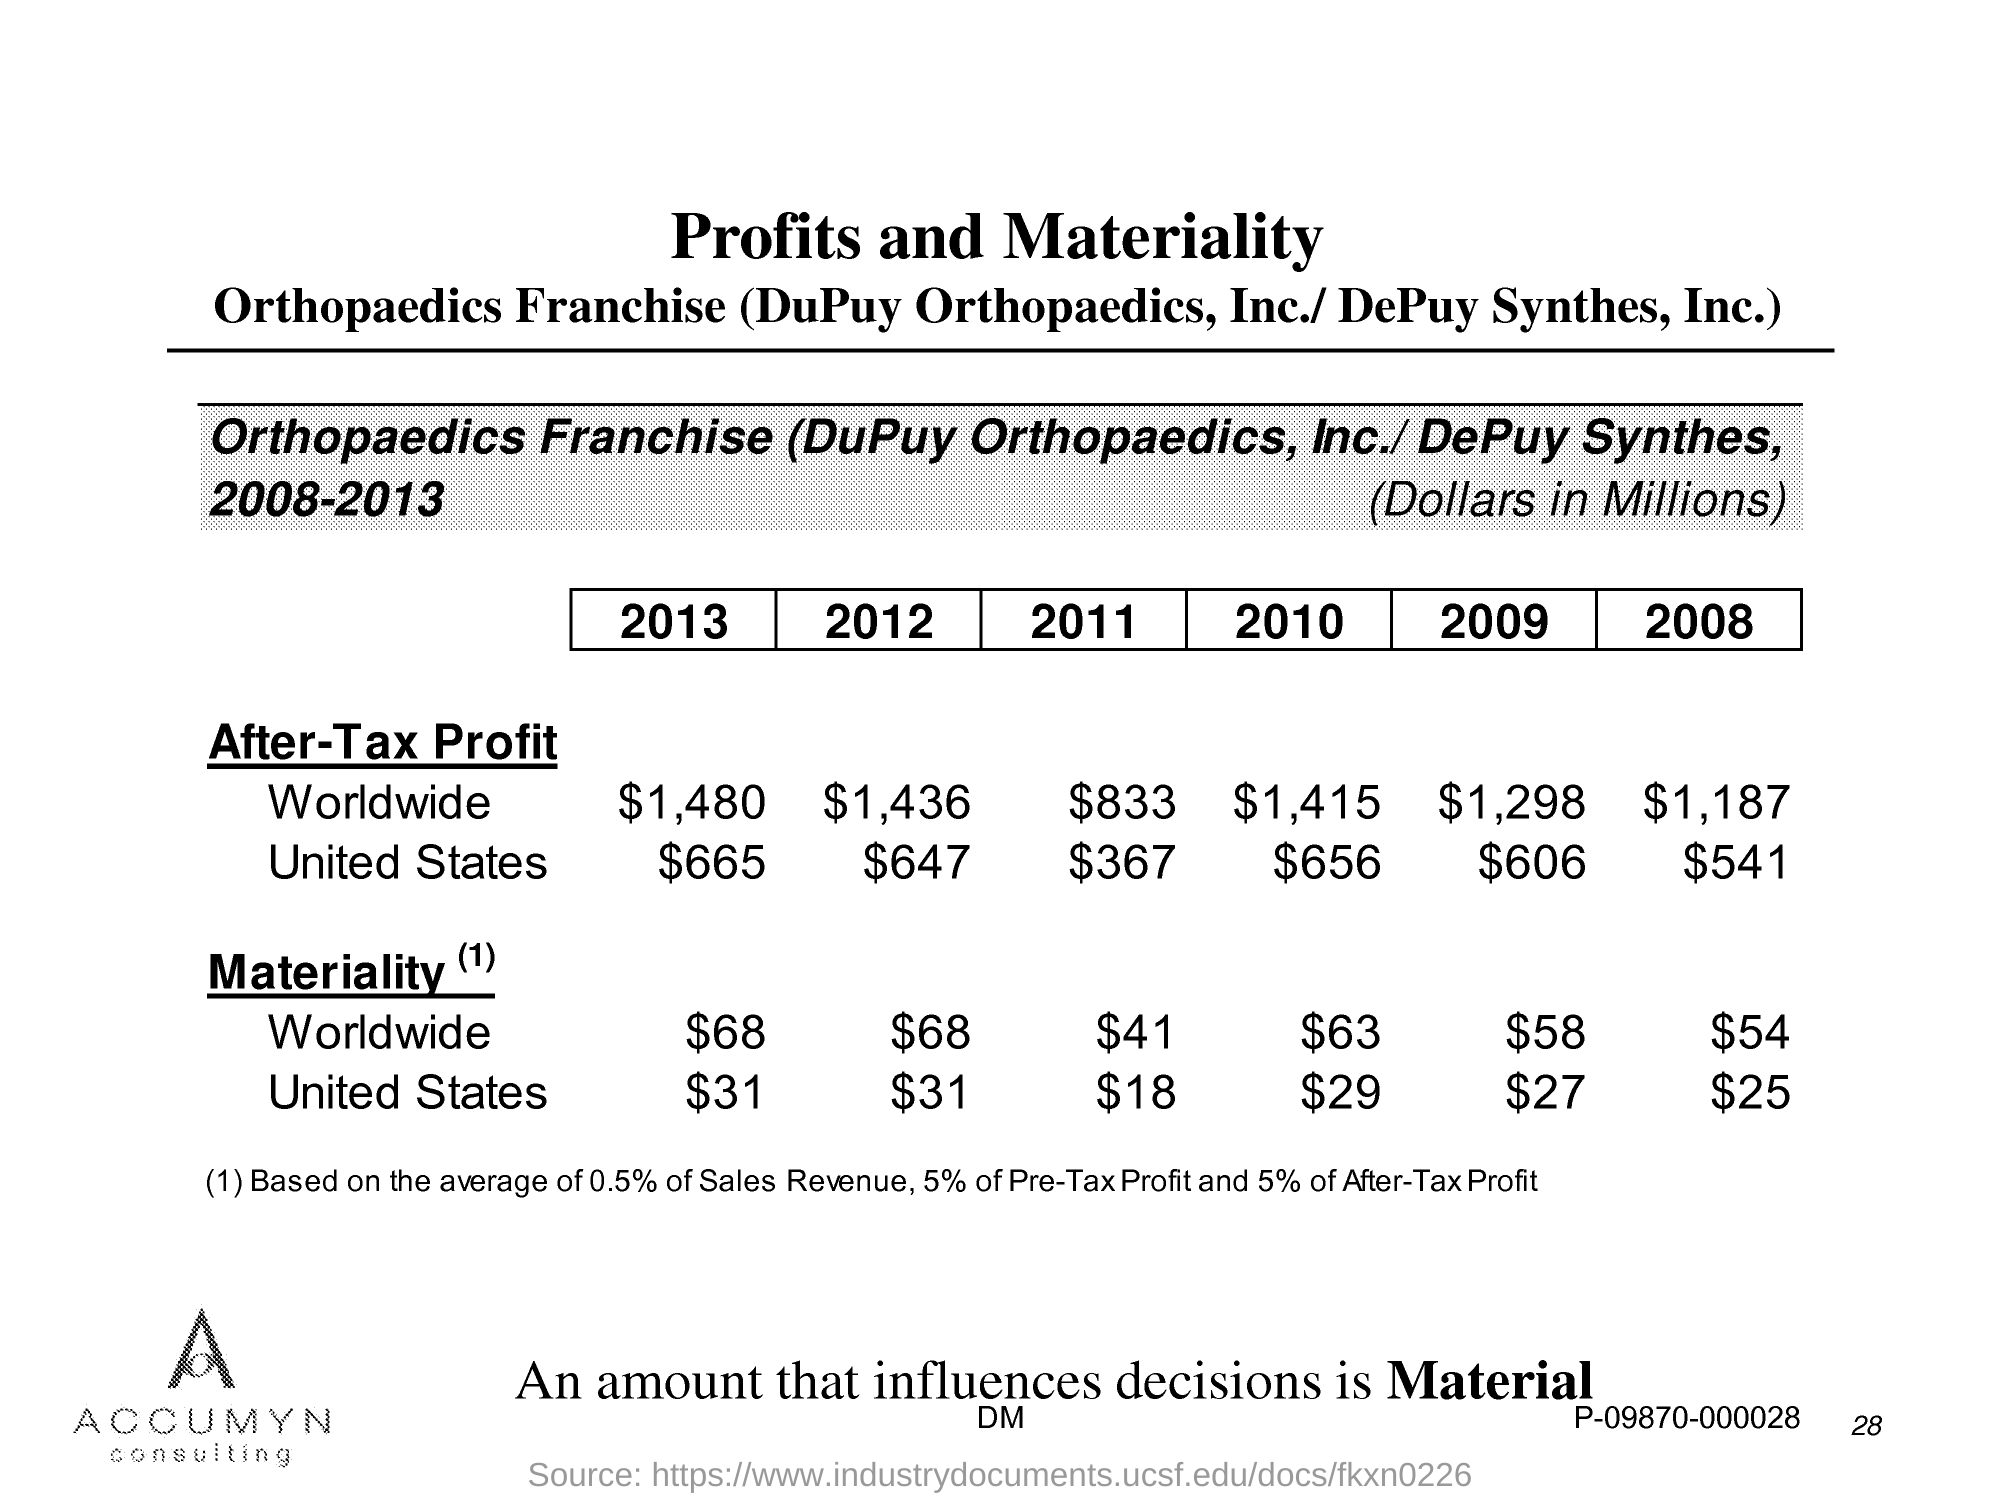What is the After-Tax  profit worldwide in the year 2013?
Offer a very short reply. $1,480. What is the After-Tax  profit worldwide in the year 2012?
Your response must be concise. $1,436. What is the After-Tax  profit worldwide in the year 2011?
Give a very brief answer. $833. What is the After-Tax  profit worldwide in the year 2010?
Provide a succinct answer. $1,415. What is the After-Tax  profit worldwide in the year 2009?
Keep it short and to the point. $1,298. What is the After-Tax  profit worldwide in the year 2008?
Your response must be concise. $1,187. What is the After-Tax profit of United States in the year 2013?
Offer a terse response. $665. What is the After-Tax profit of United States in the year 2012?
Provide a succinct answer. $647. What is the After-Tax profit of United States in the year 2011?
Provide a succinct answer. $367. What is the After-Tax profit of United States in the year 2010?
Offer a terse response. $656. 